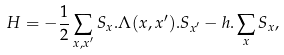<formula> <loc_0><loc_0><loc_500><loc_500>H = - \frac { 1 } { 2 } \sum _ { { x } , { x } ^ { \prime } } { S } _ { x } . \Lambda ( { x } , { x } ^ { \prime } ) . { S } _ { { x } ^ { \prime } } - { h } . \sum _ { x } { S } _ { x } ,</formula> 